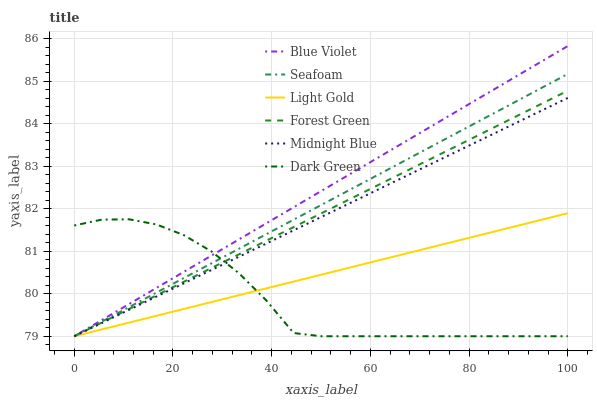Does Dark Green have the minimum area under the curve?
Answer yes or no. Yes. Does Blue Violet have the maximum area under the curve?
Answer yes or no. Yes. Does Seafoam have the minimum area under the curve?
Answer yes or no. No. Does Seafoam have the maximum area under the curve?
Answer yes or no. No. Is Light Gold the smoothest?
Answer yes or no. Yes. Is Dark Green the roughest?
Answer yes or no. Yes. Is Seafoam the smoothest?
Answer yes or no. No. Is Seafoam the roughest?
Answer yes or no. No. Does Midnight Blue have the lowest value?
Answer yes or no. Yes. Does Blue Violet have the highest value?
Answer yes or no. Yes. Does Seafoam have the highest value?
Answer yes or no. No. Does Forest Green intersect Dark Green?
Answer yes or no. Yes. Is Forest Green less than Dark Green?
Answer yes or no. No. Is Forest Green greater than Dark Green?
Answer yes or no. No. 